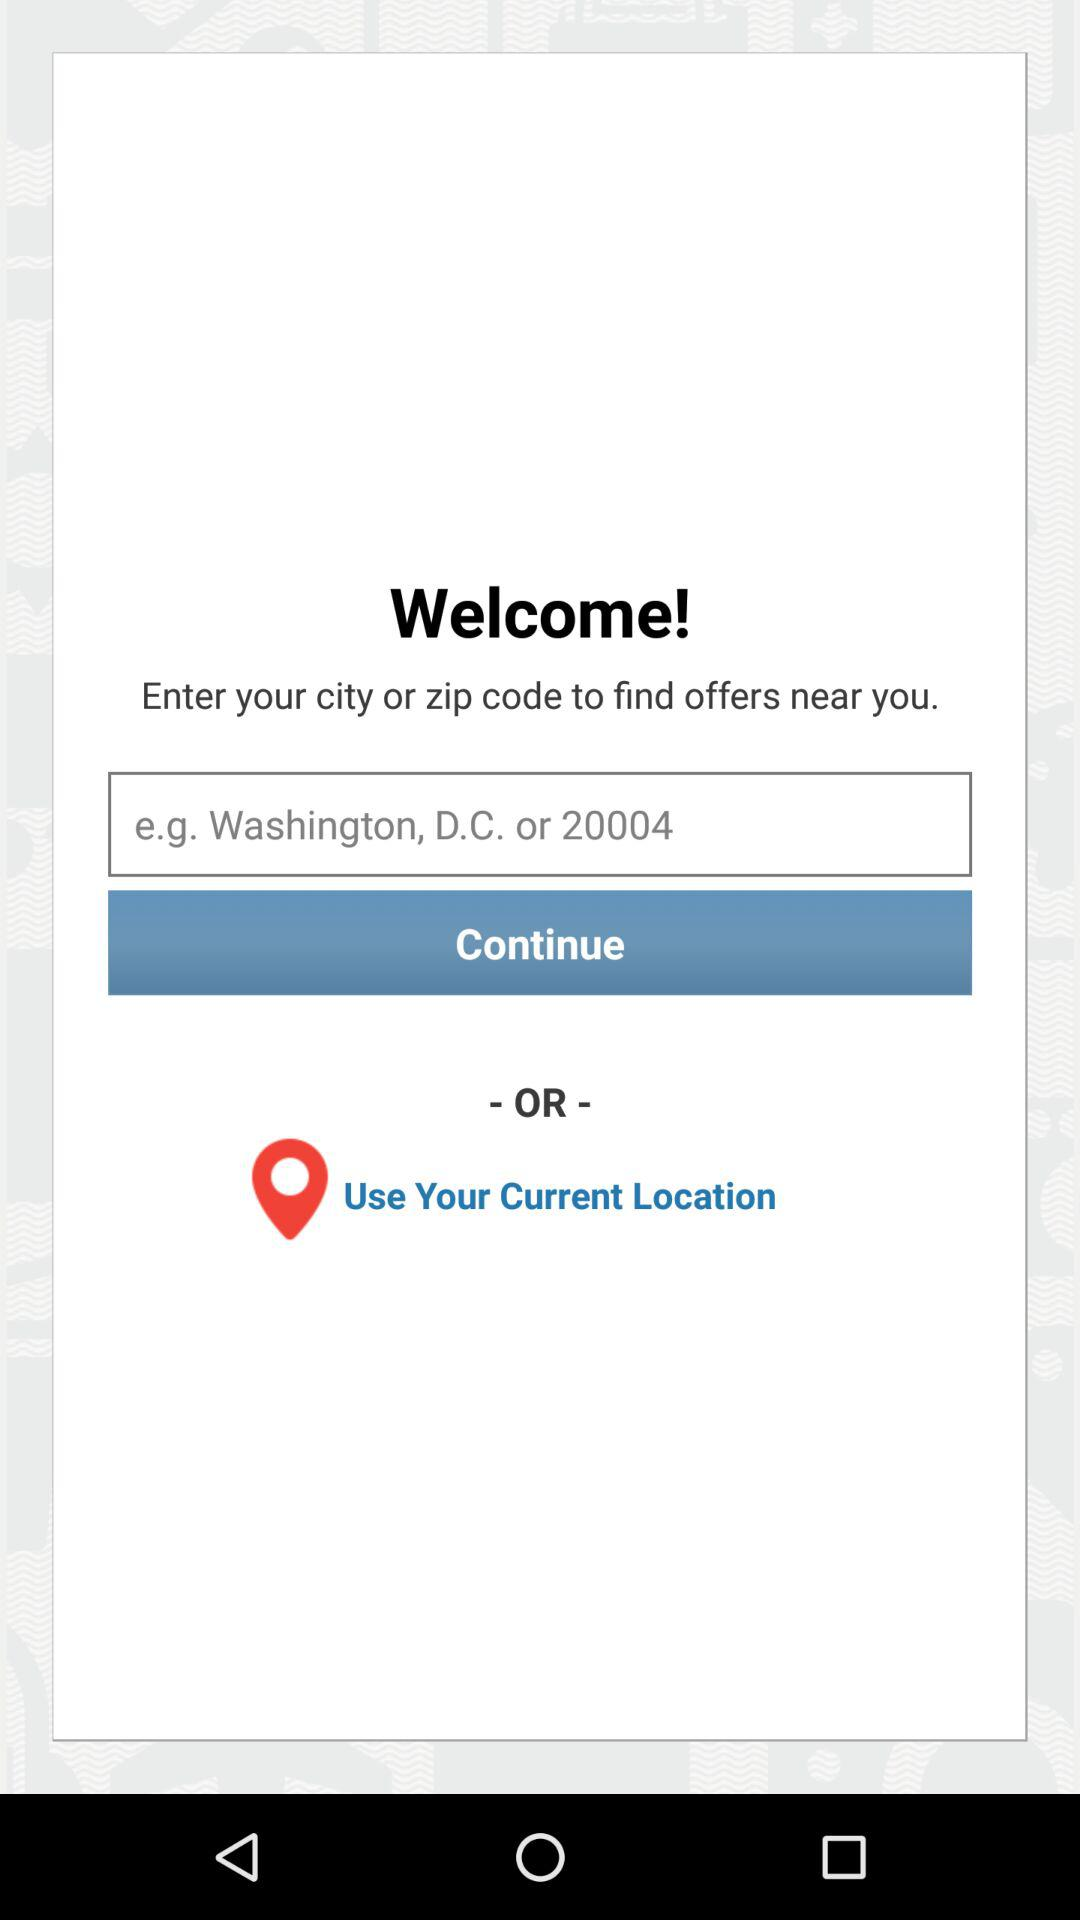How can I find an offer near me? To find an offer near you, enter your city or zip code. 